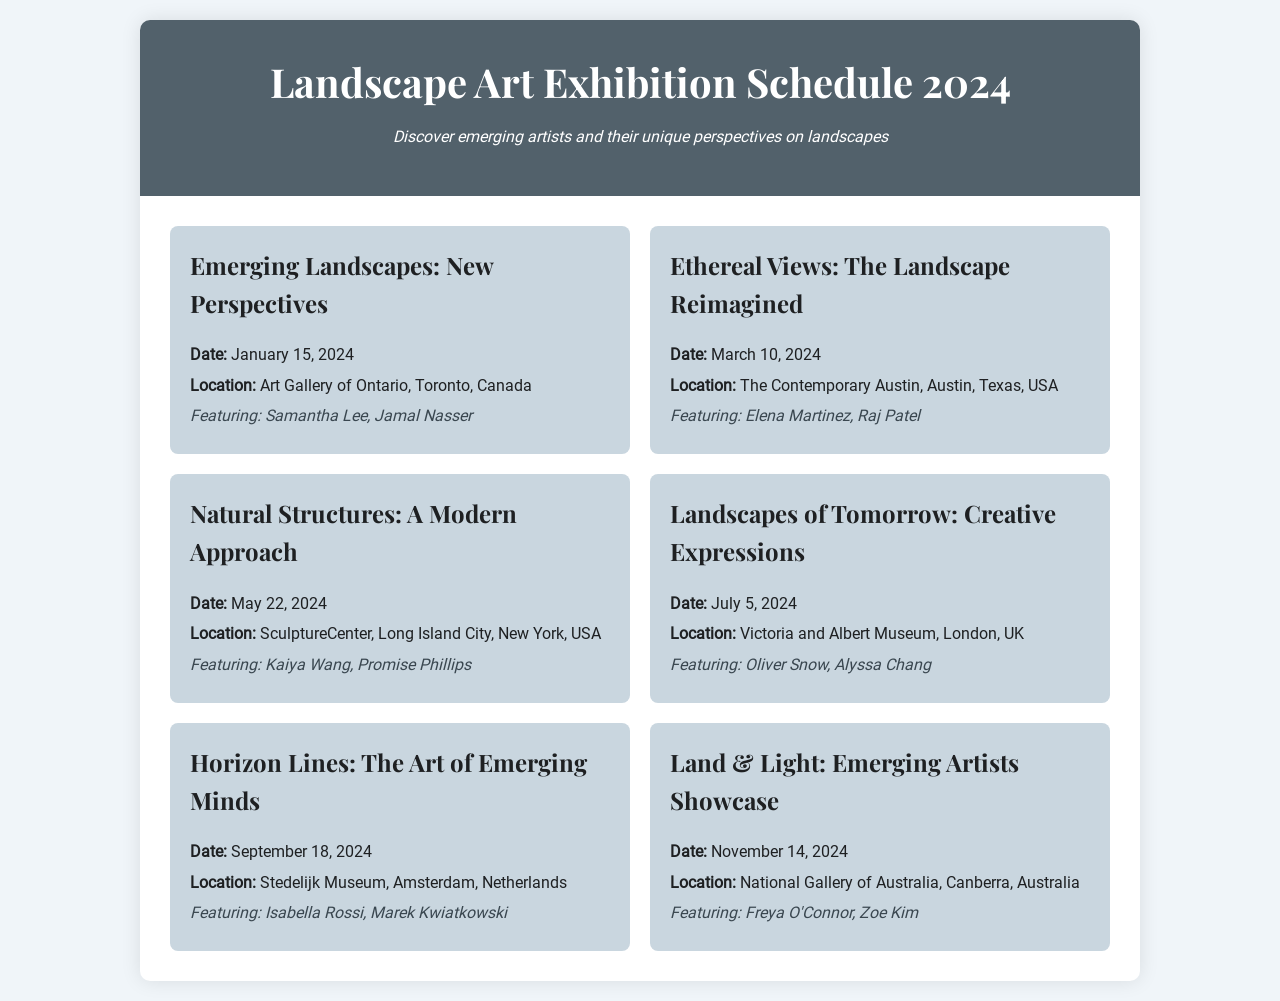What is the title of the exhibition on January 15, 2024? The title can be found at the top of the event section for that date, which is "Emerging Landscapes: New Perspectives".
Answer: Emerging Landscapes: New Perspectives Where will the exhibition on March 10, 2024, take place? The location is specified in the event details for that date, listed as "The Contemporary Austin, Austin, Texas, USA".
Answer: The Contemporary Austin, Austin, Texas, USA Who are the featured artists in the exhibition on May 22, 2024? The featured artists are listed under the event details for that date, which are "Kaiya Wang, Promise Phillips".
Answer: Kaiya Wang, Promise Phillips What is the date of the exhibition titled "Landscapes of Tomorrow: Creative Expressions"? The date is mentioned in the event details, which states "July 5, 2024".
Answer: July 5, 2024 Which exhibition features the artists "Isabella Rossi, Marek Kwiatkowski"? This information can be found in the event details for the exhibition scheduled on September 18, 2024.
Answer: Horizon Lines: The Art of Emerging Minds How many exhibitions are scheduled in total for the year 2024? By counting the total number of event entries in the schedule, there are six exhibitions listed.
Answer: Six What is the last exhibition of the year? The last entry in the document indicates the final event, which is "Land & Light: Emerging Artists Showcase" on November 14, 2024.
Answer: Land & Light: Emerging Artists Showcase In which city will the exhibition on July 5, 2024, be held? The city is mentioned in the event details for that date as "London".
Answer: London 